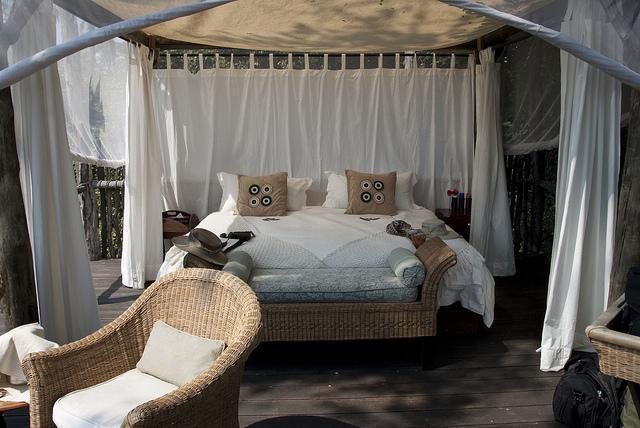How many pillows are on the bed?
Give a very brief answer. 4. How many people are facing the camera?
Give a very brief answer. 0. 